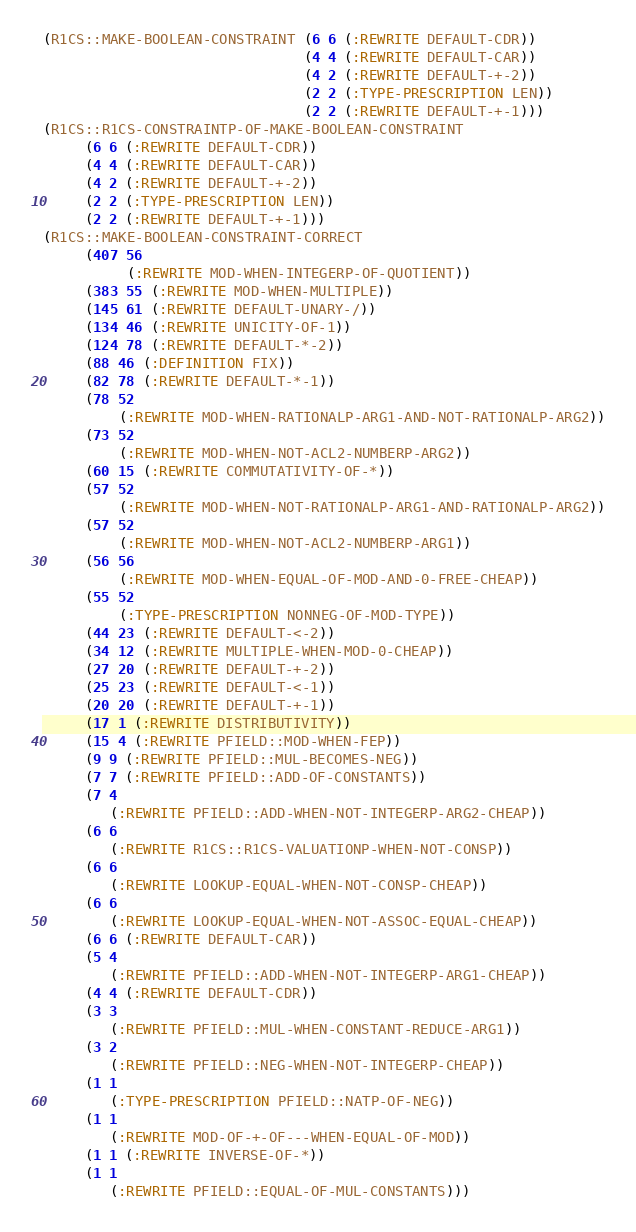<code> <loc_0><loc_0><loc_500><loc_500><_Lisp_>(R1CS::MAKE-BOOLEAN-CONSTRAINT (6 6 (:REWRITE DEFAULT-CDR))
                               (4 4 (:REWRITE DEFAULT-CAR))
                               (4 2 (:REWRITE DEFAULT-+-2))
                               (2 2 (:TYPE-PRESCRIPTION LEN))
                               (2 2 (:REWRITE DEFAULT-+-1)))
(R1CS::R1CS-CONSTRAINTP-OF-MAKE-BOOLEAN-CONSTRAINT
     (6 6 (:REWRITE DEFAULT-CDR))
     (4 4 (:REWRITE DEFAULT-CAR))
     (4 2 (:REWRITE DEFAULT-+-2))
     (2 2 (:TYPE-PRESCRIPTION LEN))
     (2 2 (:REWRITE DEFAULT-+-1)))
(R1CS::MAKE-BOOLEAN-CONSTRAINT-CORRECT
     (407 56
          (:REWRITE MOD-WHEN-INTEGERP-OF-QUOTIENT))
     (383 55 (:REWRITE MOD-WHEN-MULTIPLE))
     (145 61 (:REWRITE DEFAULT-UNARY-/))
     (134 46 (:REWRITE UNICITY-OF-1))
     (124 78 (:REWRITE DEFAULT-*-2))
     (88 46 (:DEFINITION FIX))
     (82 78 (:REWRITE DEFAULT-*-1))
     (78 52
         (:REWRITE MOD-WHEN-RATIONALP-ARG1-AND-NOT-RATIONALP-ARG2))
     (73 52
         (:REWRITE MOD-WHEN-NOT-ACL2-NUMBERP-ARG2))
     (60 15 (:REWRITE COMMUTATIVITY-OF-*))
     (57 52
         (:REWRITE MOD-WHEN-NOT-RATIONALP-ARG1-AND-RATIONALP-ARG2))
     (57 52
         (:REWRITE MOD-WHEN-NOT-ACL2-NUMBERP-ARG1))
     (56 56
         (:REWRITE MOD-WHEN-EQUAL-OF-MOD-AND-0-FREE-CHEAP))
     (55 52
         (:TYPE-PRESCRIPTION NONNEG-OF-MOD-TYPE))
     (44 23 (:REWRITE DEFAULT-<-2))
     (34 12 (:REWRITE MULTIPLE-WHEN-MOD-0-CHEAP))
     (27 20 (:REWRITE DEFAULT-+-2))
     (25 23 (:REWRITE DEFAULT-<-1))
     (20 20 (:REWRITE DEFAULT-+-1))
     (17 1 (:REWRITE DISTRIBUTIVITY))
     (15 4 (:REWRITE PFIELD::MOD-WHEN-FEP))
     (9 9 (:REWRITE PFIELD::MUL-BECOMES-NEG))
     (7 7 (:REWRITE PFIELD::ADD-OF-CONSTANTS))
     (7 4
        (:REWRITE PFIELD::ADD-WHEN-NOT-INTEGERP-ARG2-CHEAP))
     (6 6
        (:REWRITE R1CS::R1CS-VALUATIONP-WHEN-NOT-CONSP))
     (6 6
        (:REWRITE LOOKUP-EQUAL-WHEN-NOT-CONSP-CHEAP))
     (6 6
        (:REWRITE LOOKUP-EQUAL-WHEN-NOT-ASSOC-EQUAL-CHEAP))
     (6 6 (:REWRITE DEFAULT-CAR))
     (5 4
        (:REWRITE PFIELD::ADD-WHEN-NOT-INTEGERP-ARG1-CHEAP))
     (4 4 (:REWRITE DEFAULT-CDR))
     (3 3
        (:REWRITE PFIELD::MUL-WHEN-CONSTANT-REDUCE-ARG1))
     (3 2
        (:REWRITE PFIELD::NEG-WHEN-NOT-INTEGERP-CHEAP))
     (1 1
        (:TYPE-PRESCRIPTION PFIELD::NATP-OF-NEG))
     (1 1
        (:REWRITE MOD-OF-+-OF---WHEN-EQUAL-OF-MOD))
     (1 1 (:REWRITE INVERSE-OF-*))
     (1 1
        (:REWRITE PFIELD::EQUAL-OF-MUL-CONSTANTS)))
</code> 